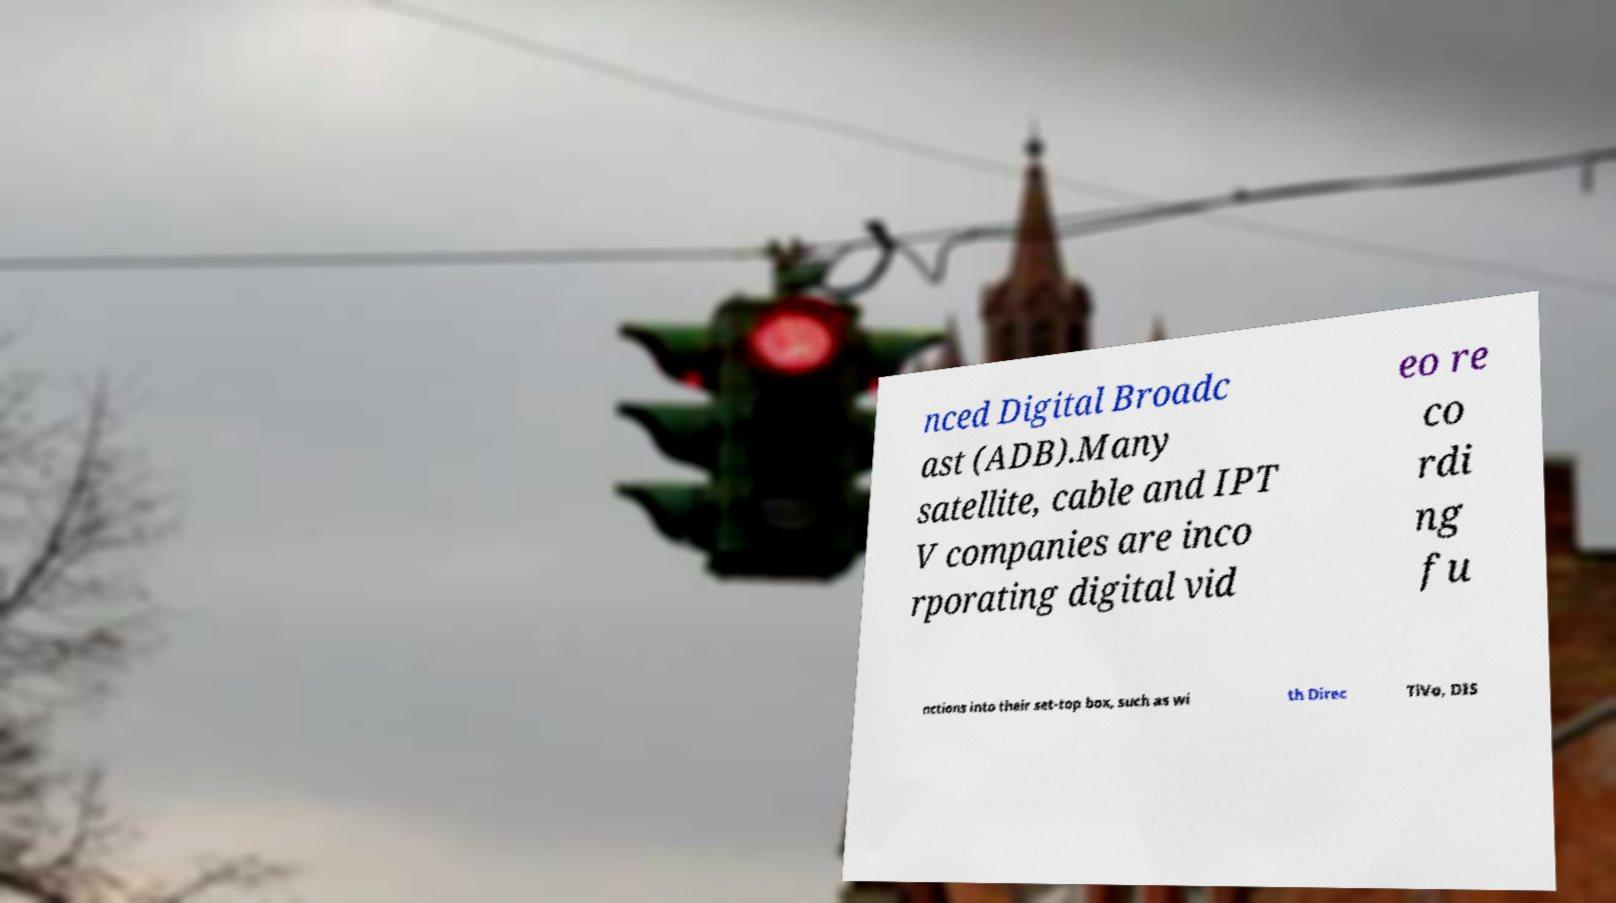I need the written content from this picture converted into text. Can you do that? nced Digital Broadc ast (ADB).Many satellite, cable and IPT V companies are inco rporating digital vid eo re co rdi ng fu nctions into their set-top box, such as wi th Direc TiVo, DIS 